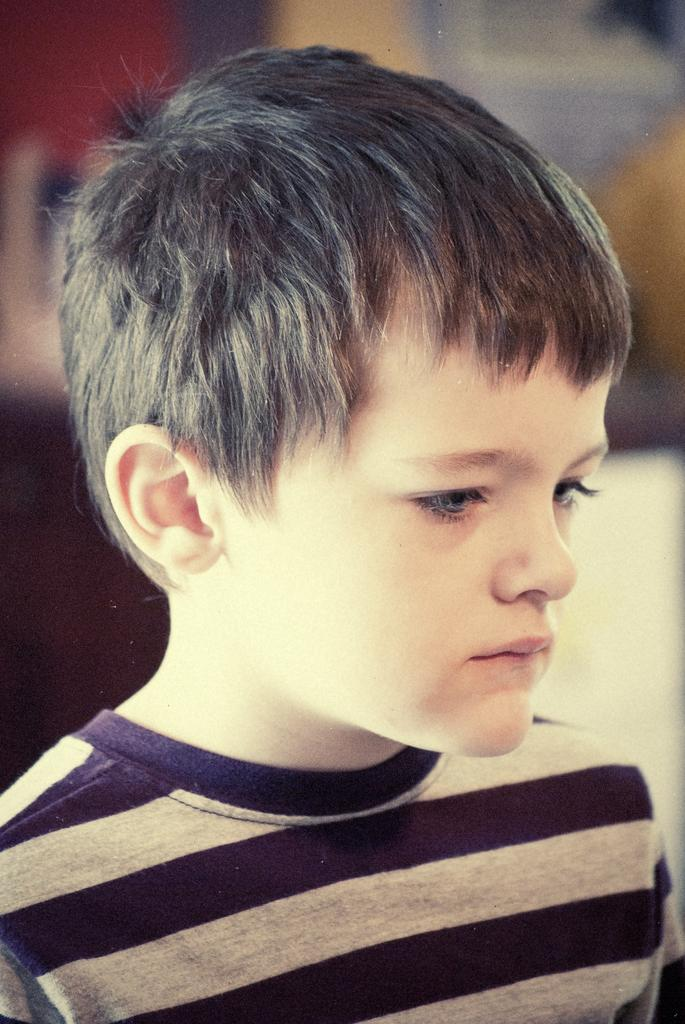What is the main subject of the image? The main subject of the image is a kid. What can be observed about the kid's attire? The kid is wearing clothes. Can you describe the background of the image? The background of the image is blurred. How much money is the kid holding in the image? There is no indication of money in the image; the kid is not holding any. What type of pickle can be seen in the image? There is no pickle present in the image. 